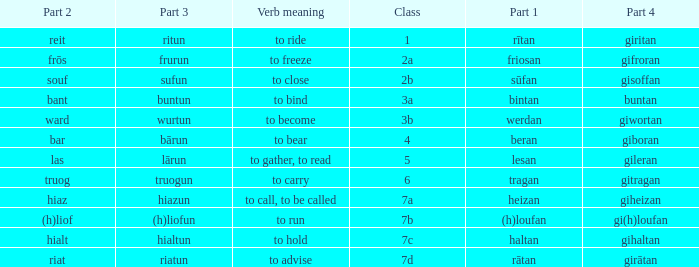What is the part 3 of the word in class 7a? Hiazun. 